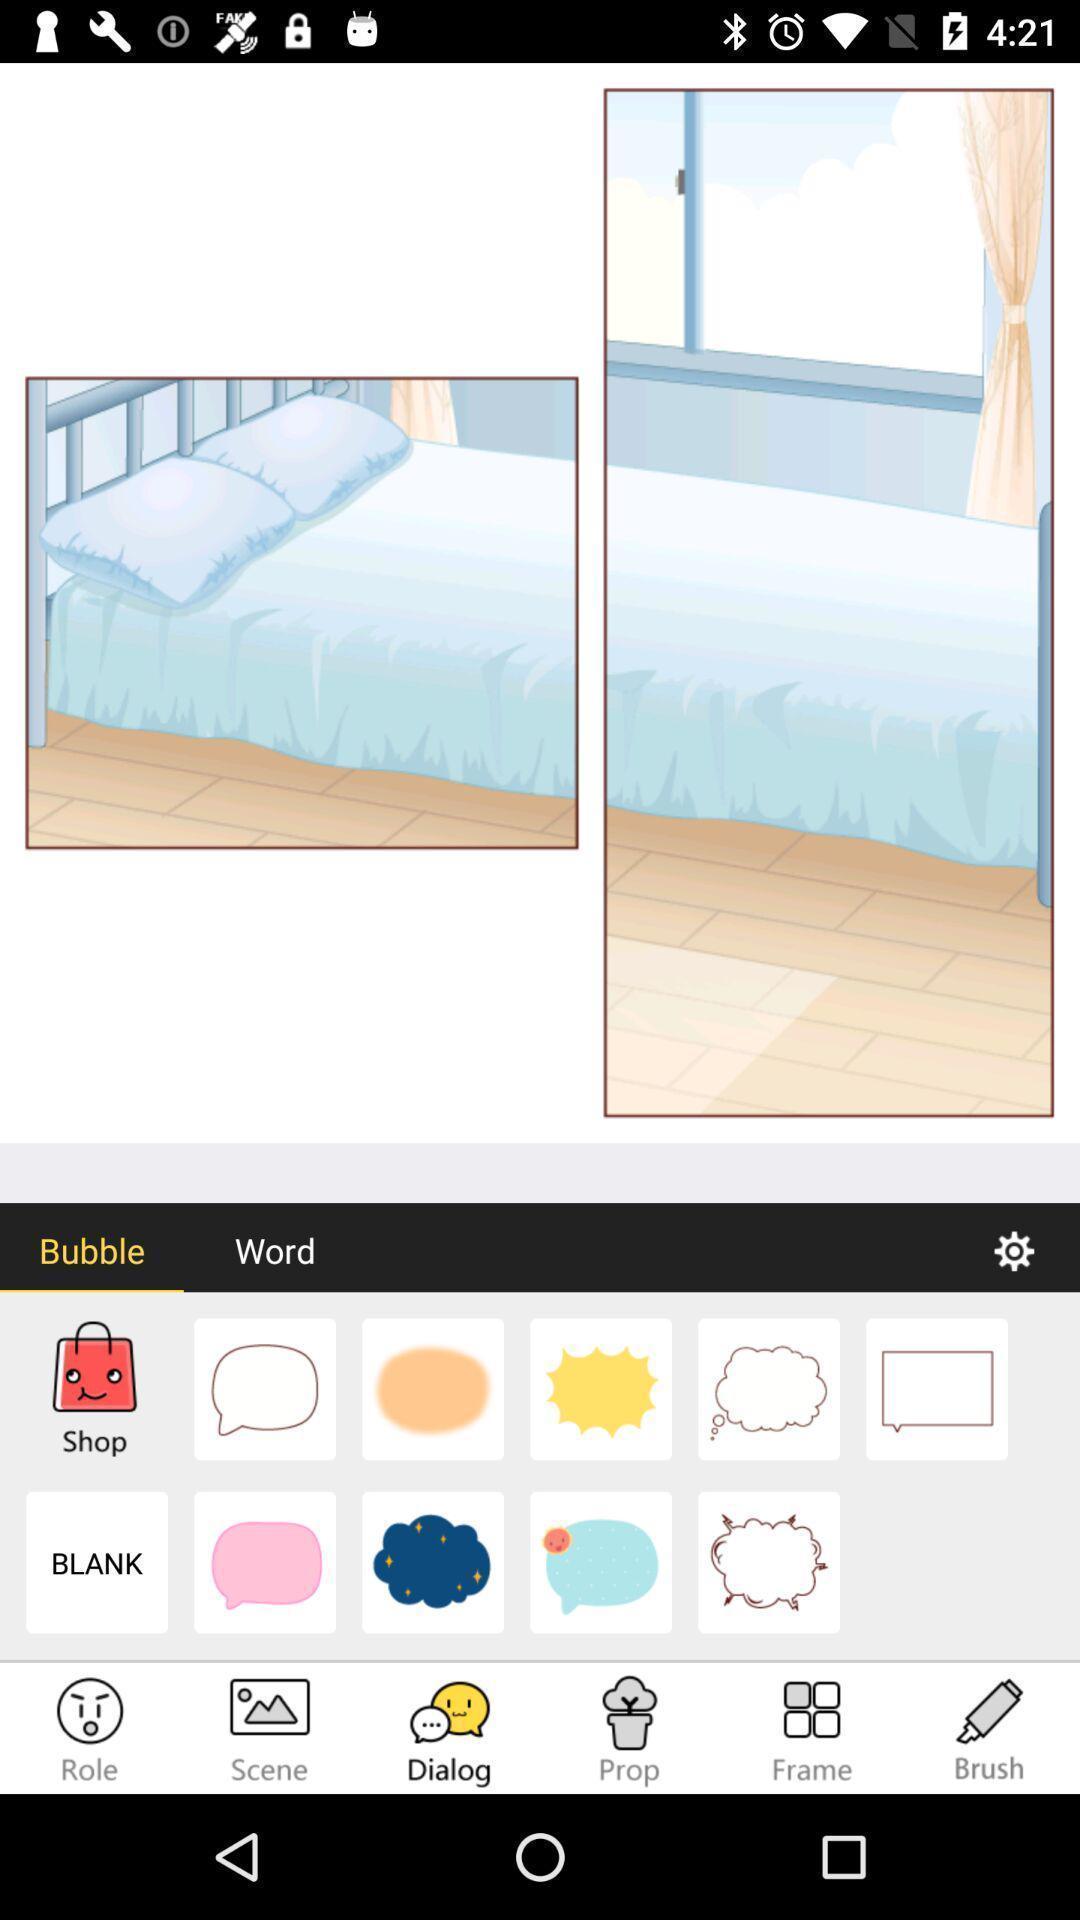Give me a summary of this screen capture. Screen showing various edit options of a photo app. 